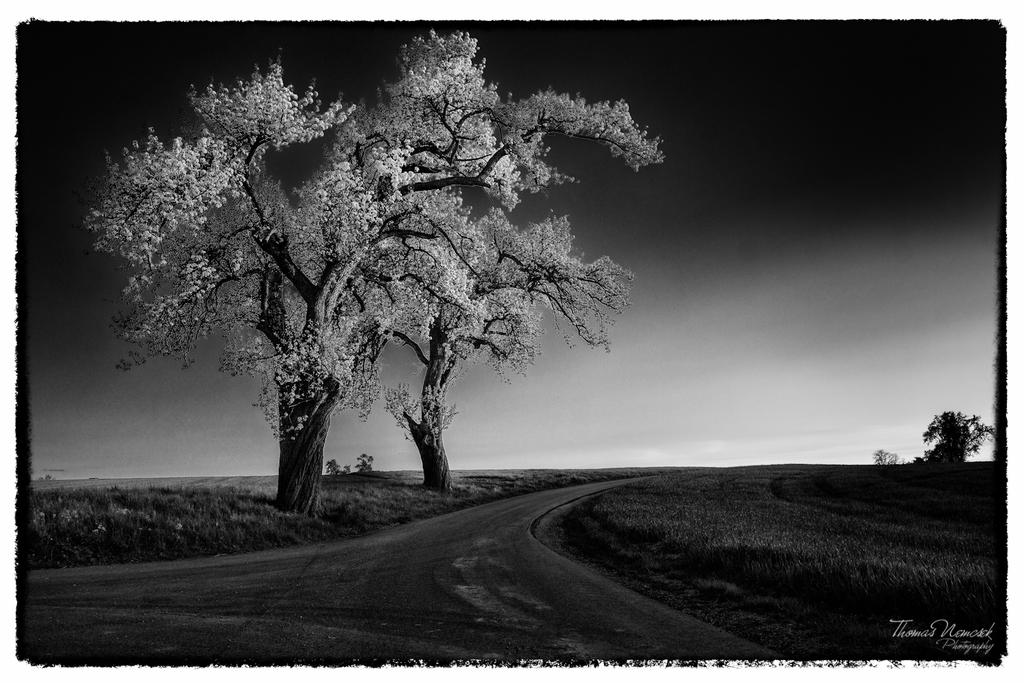What is the color scheme of the image? The image is black and white. What can be seen in the middle of the image? There are trees in the middle of the image. What is located at the bottom of the image? There is a road at the bottom of the image. What type of vegetation is on the right side of the image? There is grass on the right side of the image. What is visible at the top of the image? The sky is visible at the top of the image. What type of hair can be seen on the trees in the image? There is no hair present on the trees in the image, as trees do not have hair. What type of border is visible around the image? The image does not show any borders; it only shows the scene described in the facts. 